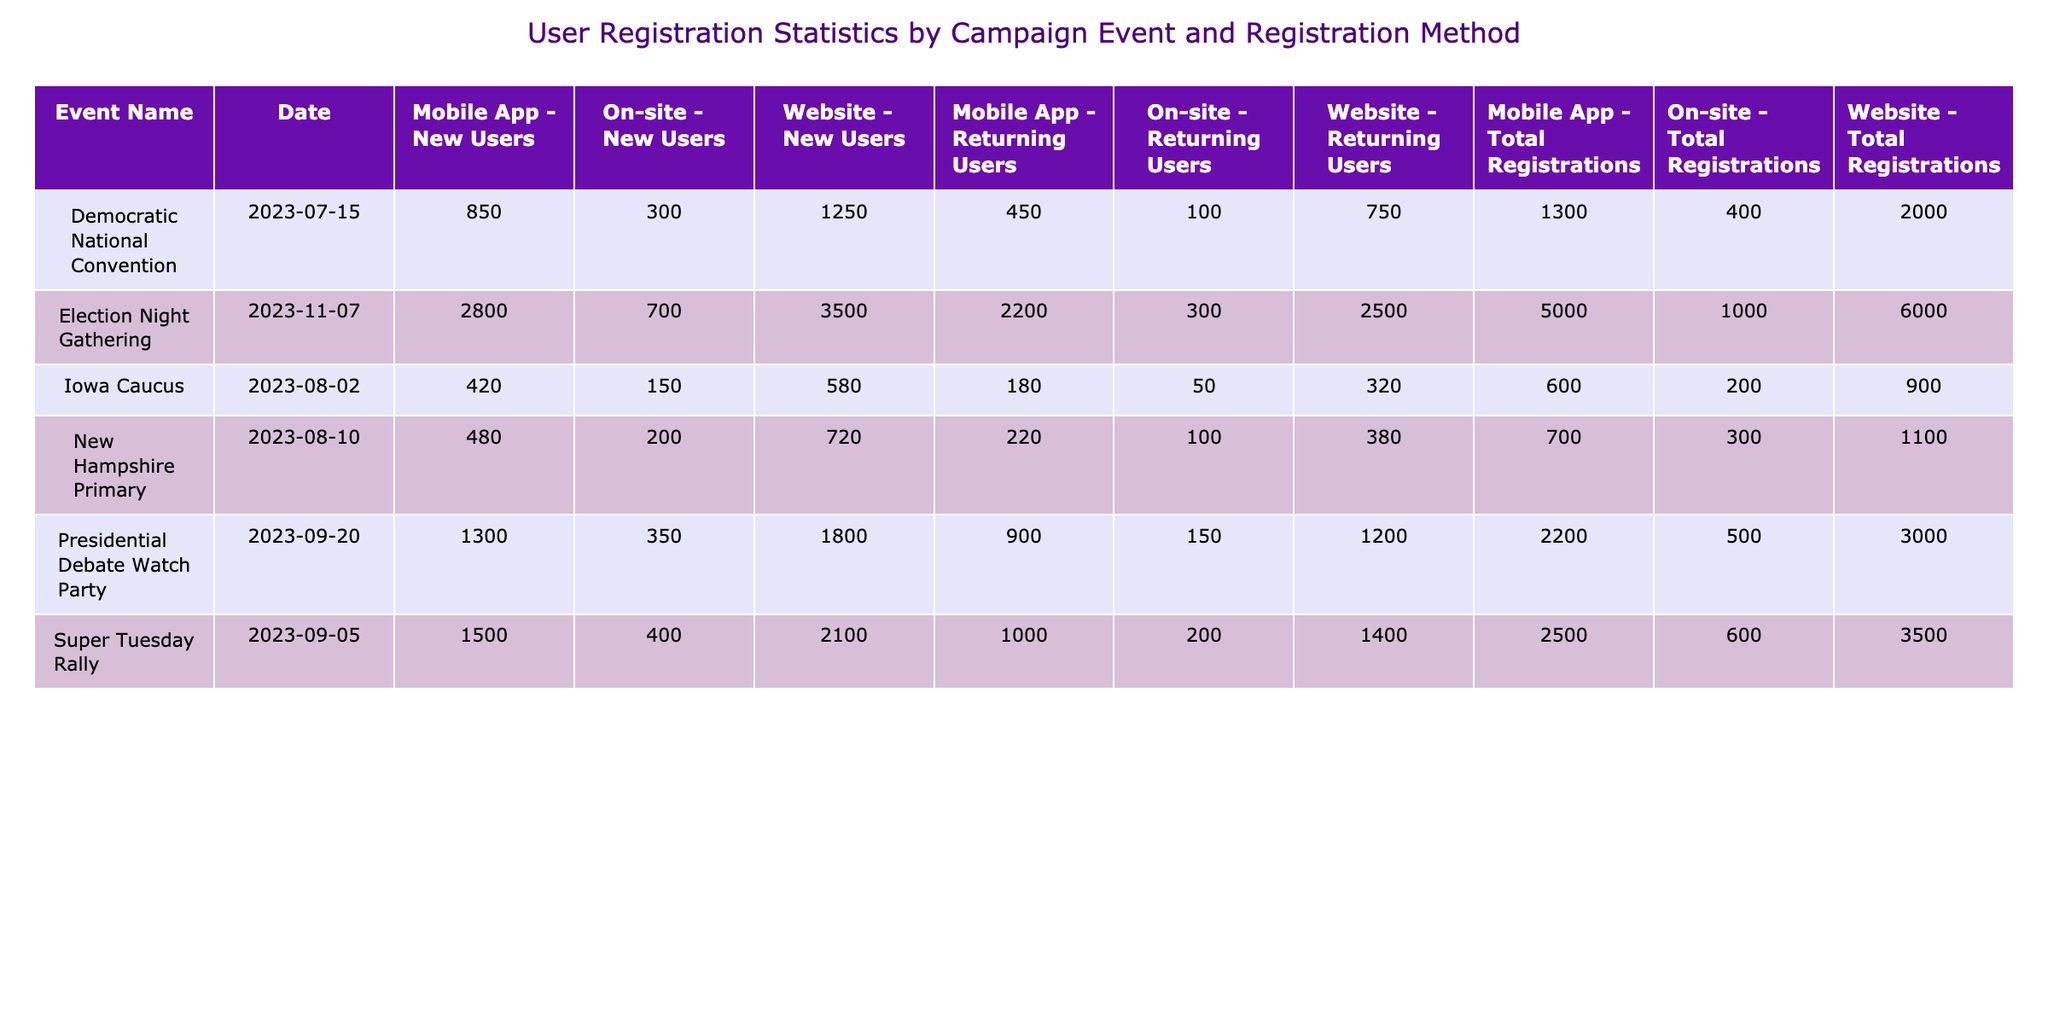What is the total number of registrations for the Super Tuesday Rally? The total registrations for the Super Tuesday Rally can be found in the corresponding row for that event. It states that the total registrations are 3500.
Answer: 3500 Which event received the highest number of new users through the website? By comparing the values of new users for each event's website registrations, the Democratic National Convention has 1250 new users, while other events like Super Tuesday Rally and Election Night Gathering have 2100 and 3500 respectively. The highest is 3500 for the Election Night Gathering.
Answer: 3500 What is the total number of registrations from mobile app users for the Iowa Caucus? Referring to the row for the Iowa Caucus, the total registrations from the mobile app can be found directly, which is stated as 600.
Answer: 600 Did the New Hampshire Primary have more total registrations than the Iowa Caucus? For the New Hampshire Primary, the total registrations are 1100, while for the Iowa Caucus, total registrations are 900. By comparing these two values, New Hampshire Primary had more total registrations.
Answer: Yes What are the total registrations for the Election Night Gathering as compared to the Presidential Debate Watch Party? The total registrations for the Election Night Gathering is 6000, and for the Presidential Debate Watch Party, it’s 3000. Therefore, the former has more registrations. To find the difference, we can subtract: 6000 - 3000 = 3000.
Answer: 3000 more for Election Night Gathering What are the average total registrations for events held on-site across all campaigns? First, identify the total registrations on-site for each event: 400 (DNC) + 200 (Iowa) + 300 (NH) + 600 (Super Tuesday) + 500 (Debate) + 1000 (Election Night) = 3000. There are 6 events, so 3000/6 = 500 on average.
Answer: 500 Which registration method had the highest number of total registrations across all events? Summing up total registrations for each method: Website (2000 + 900 + 1100 + 3500 + 3000 + 6000 = 16700), Mobile App (1300 + 600 + 700 + 2500 + 2200 + 5000 = 17700), and On-site (400 + 200 + 300 + 600 + 500 + 1000 = 3000). The mobile app had the highest registrations with 17700.
Answer: Mobile App How many returning users registered through the mobile app for the Super Tuesday Rally? Looking at the Super Tuesday Rally's mobile app registration, it states that there are 1000 returning users.
Answer: 1000 